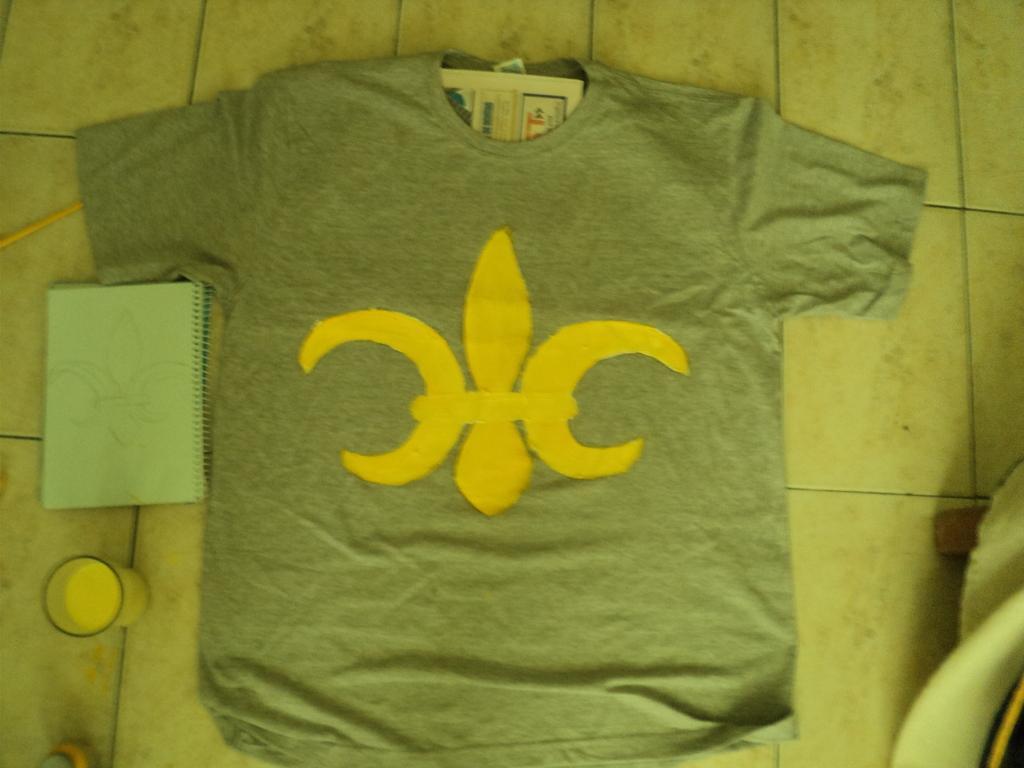In one or two sentences, can you explain what this image depicts? In this image I can see a grey colour t shirt in the centre. On this t shirt I can see a yellow colour logo and on the left side of this t shirt I can see a book and a glass. On the right side of this image I can see few stuffs. 